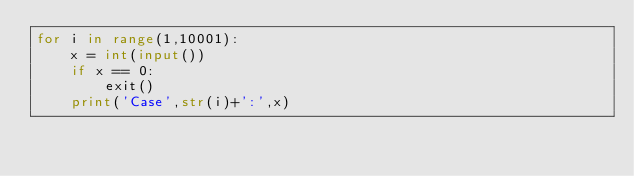Convert code to text. <code><loc_0><loc_0><loc_500><loc_500><_Python_>for i in range(1,10001):
    x = int(input())
    if x == 0:
        exit()
    print('Case',str(i)+':',x)
</code> 